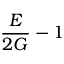<formula> <loc_0><loc_0><loc_500><loc_500>{ \frac { E } { 2 G } } - 1</formula> 